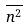<formula> <loc_0><loc_0><loc_500><loc_500>\overline { n ^ { 2 } }</formula> 